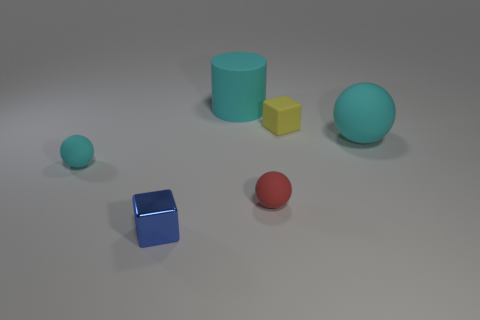Are there fewer red matte spheres that are to the left of the big cylinder than small rubber cylinders?
Offer a terse response. No. The blue metal thing that is the same size as the yellow rubber block is what shape?
Your answer should be very brief. Cube. What number of other objects are there of the same color as the rubber cylinder?
Keep it short and to the point. 2. Does the blue metallic object have the same size as the red matte thing?
Give a very brief answer. Yes. What number of objects are either metal cubes or cyan things behind the tiny cyan rubber object?
Ensure brevity in your answer.  3. Are there fewer blue metallic cubes on the right side of the tiny blue thing than blue metallic things behind the matte cylinder?
Offer a very short reply. No. What number of other things are there of the same material as the small blue cube
Ensure brevity in your answer.  0. There is a big rubber object behind the yellow matte thing; is it the same color as the large sphere?
Your response must be concise. Yes. Are there any tiny blue metallic things behind the cyan matte thing that is on the left side of the cyan matte cylinder?
Keep it short and to the point. No. What material is the cyan object that is to the left of the tiny red sphere and in front of the cyan cylinder?
Give a very brief answer. Rubber. 